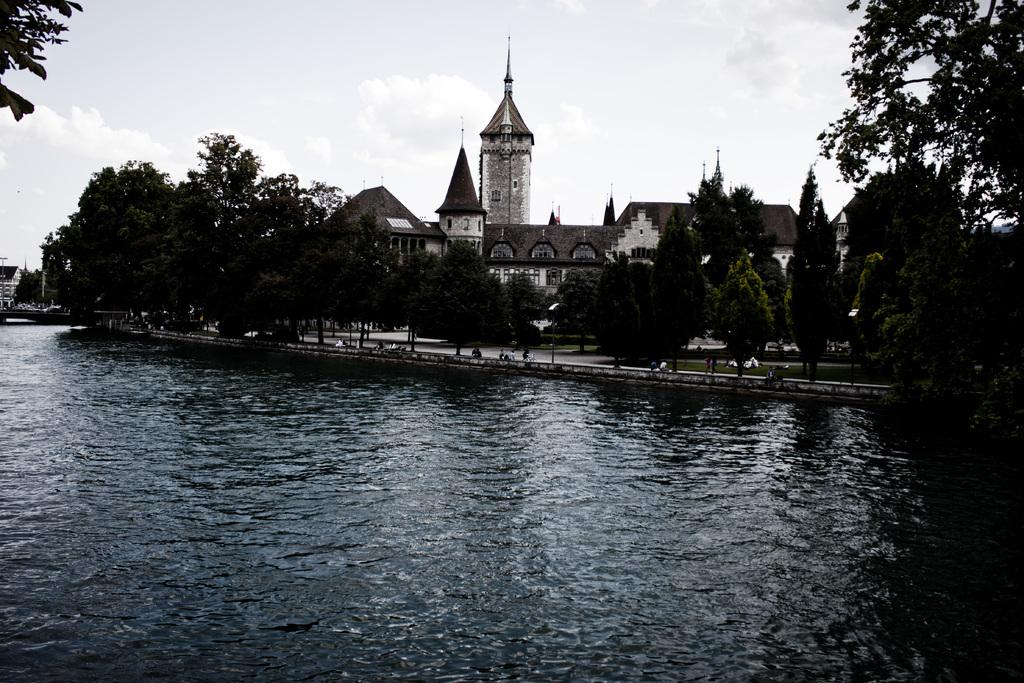What is located in the foreground of the picture? There is a river in the foreground of the picture. What can be seen in the center of the picture? There are trees, grass, and a castle in the center of the picture. What is the condition of the sky in the picture? The sky is cloudy in the picture. Can you tell me where the border between the trees and the grass is located in the image? There is no specific border between the trees and the grass mentioned in the facts, as they are both described as being in the center of the picture. What type of calculator can be seen in the image? There is no calculator present in the image. 